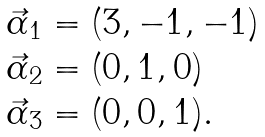Convert formula to latex. <formula><loc_0><loc_0><loc_500><loc_500>\begin{array} { l } \vec { \alpha } _ { 1 } = ( 3 , - 1 , - 1 ) \\ \vec { \alpha } _ { 2 } = ( 0 , 1 , 0 ) \\ \vec { \alpha } _ { 3 } = ( 0 , 0 , 1 ) . \end{array}</formula> 